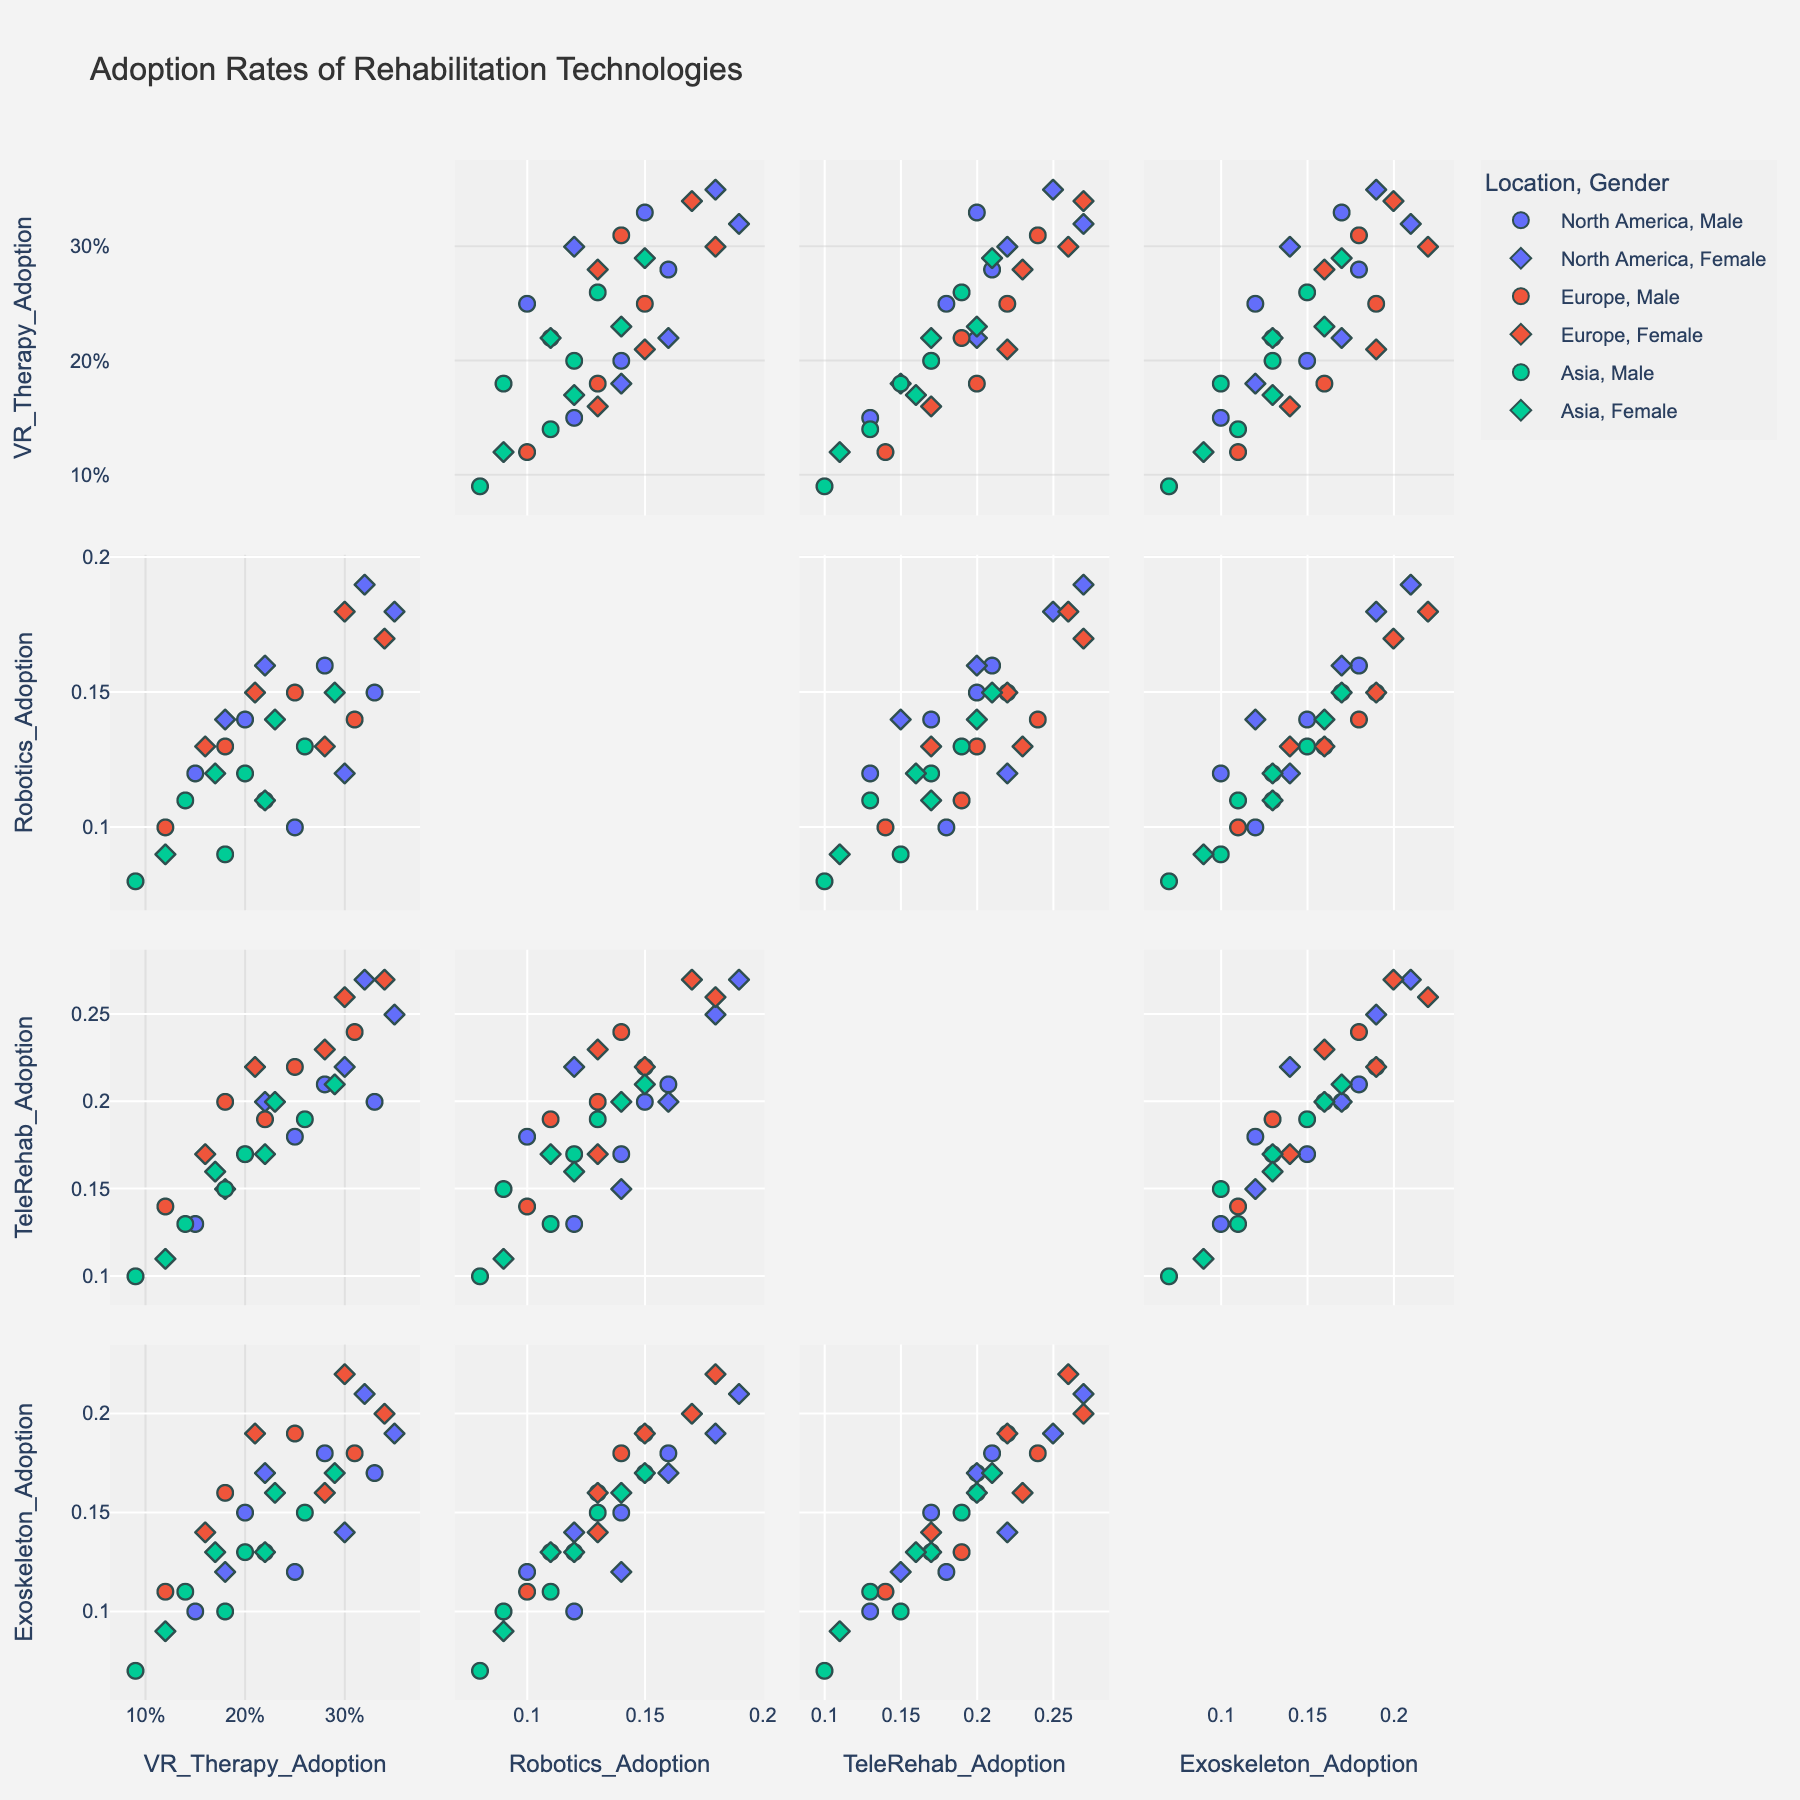What's the title of the scatter plot matrix figure? The title is typically located at the top of the plot. On inspecting, the title of the plot shows: "Adoption Rates of Rehabilitation Technologies".
Answer: Adoption Rates of Rehabilitation Technologies How do the adoption rates for VR Therapy and Robotics compare for males in North America across all age groups? Look at the scatter plots comparing VR Therapy Adoption and Robotics Adoption and filter the points marked 'Male' and 'North America'. Across different age groups, VR Therapy generally has higher adoption rates than Robotics for males in North America (e.g., 0.25 vs. 0.10, 0.33 vs. 0.15, etc.).
Answer: VR Therapy rates are higher Which age and gender group in North America has the highest adoption rate for TeleRehab? Examine the scatter plots involving TeleRehab Adoption for points corresponding to North America-based groups of different ages and genders. Females aged 36-45 in North America have the highest TeleRehab adoption rate of 0.27.
Answer: Females aged 36-45 What is the relationship between TeleRehab Adoption and Exoskeleton Adoption for Asia across all age groups? Check the scatter plot comparing TeleRehab Adoption and Exoskeleton Adoption for regions marked 'Asia'. The points tend to cluster and slope diagonally indicating a positive relationship - as TeleRehab adoption increases, Exoskeleton adoption also increases.
Answer: Positive relationship Compare the adoption rates of VR Therapy in North America and Asia for the 26-35 age group. Look at the scatter plots involving VR Therapy Adoption, focusing on points of the 26-35 age group for regions marked 'North America' and 'Asia'. In North America, it's 0.33 for males and 0.35 for females. In Asia, it's 0.26 for males and 0.29 for females.
Answer: Higher in North America Which region has generally higher adoption rates of Robotics, North America or Europe? For points representing North America and Europe, examine the scatter plots involving Robotics Adoption. Overall, North America has slightly higher rates compared to Europe across most age and gender groups.
Answer: North America Identify the subgroup with the lowest adoption rate of Exoskeletons in Asia. Check the scatter plots involving Exoskeleton Adoption and locate points marked 'Asia'. Males aged 56-65 in Asia show the lowest adoption rate with a value of 0.07.
Answer: Males aged 56-65 Is there a visible difference in VR Therapy adoption between males and females in Europe for the 18-25 age group? Look at the scatter plots for VR Therapy Adoption involving points for 18-25 age group in Europe marked by symbols 'Male' and 'Female'. There is a difference; males exhibit 0.22 while females exhibit 0.28.
Answer: Yes Are there any noticeable trends in the adoption rates of TeleRehab as age increases across the regions? Observe the scatter plots involving TeleRehab Adoption across different age groups and locations. The trend usually shows a decline in adoption rates of TeleRehab as age increases in each region.
Answer: Adoption declines with age 